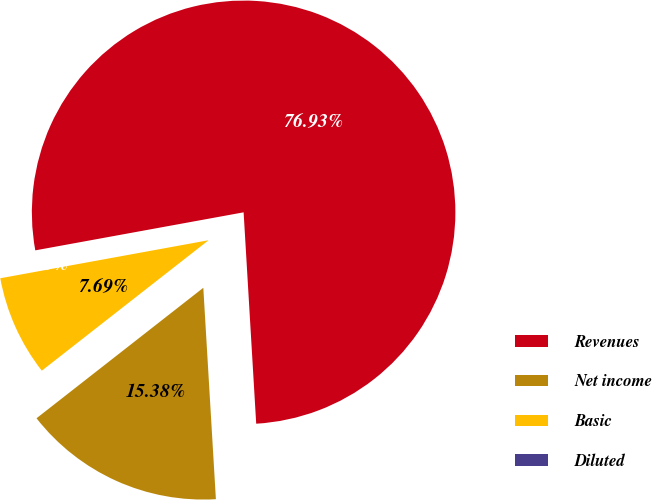Convert chart. <chart><loc_0><loc_0><loc_500><loc_500><pie_chart><fcel>Revenues<fcel>Net income<fcel>Basic<fcel>Diluted<nl><fcel>76.92%<fcel>15.38%<fcel>7.69%<fcel>0.0%<nl></chart> 